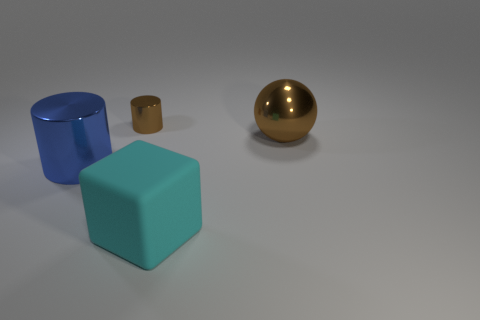Is there anything else that has the same size as the brown cylinder?
Provide a short and direct response. No. How big is the thing that is both to the right of the small thing and behind the large matte block?
Keep it short and to the point. Large. What number of rubber objects are tiny red spheres or small cylinders?
Your response must be concise. 0. There is a thing that is on the left side of the small metal cylinder; does it have the same shape as the big metallic thing behind the big blue metal object?
Give a very brief answer. No. Are there any tiny purple objects that have the same material as the brown cylinder?
Your answer should be very brief. No. The big matte block is what color?
Ensure brevity in your answer.  Cyan. What size is the thing on the right side of the cyan block?
Offer a very short reply. Large. What number of big matte cubes are the same color as the sphere?
Make the answer very short. 0. Is there a large blue metallic object left of the big metal thing in front of the big metallic sphere?
Make the answer very short. No. Do the cylinder that is to the left of the small metallic cylinder and the metal object that is to the right of the cyan object have the same color?
Give a very brief answer. No. 